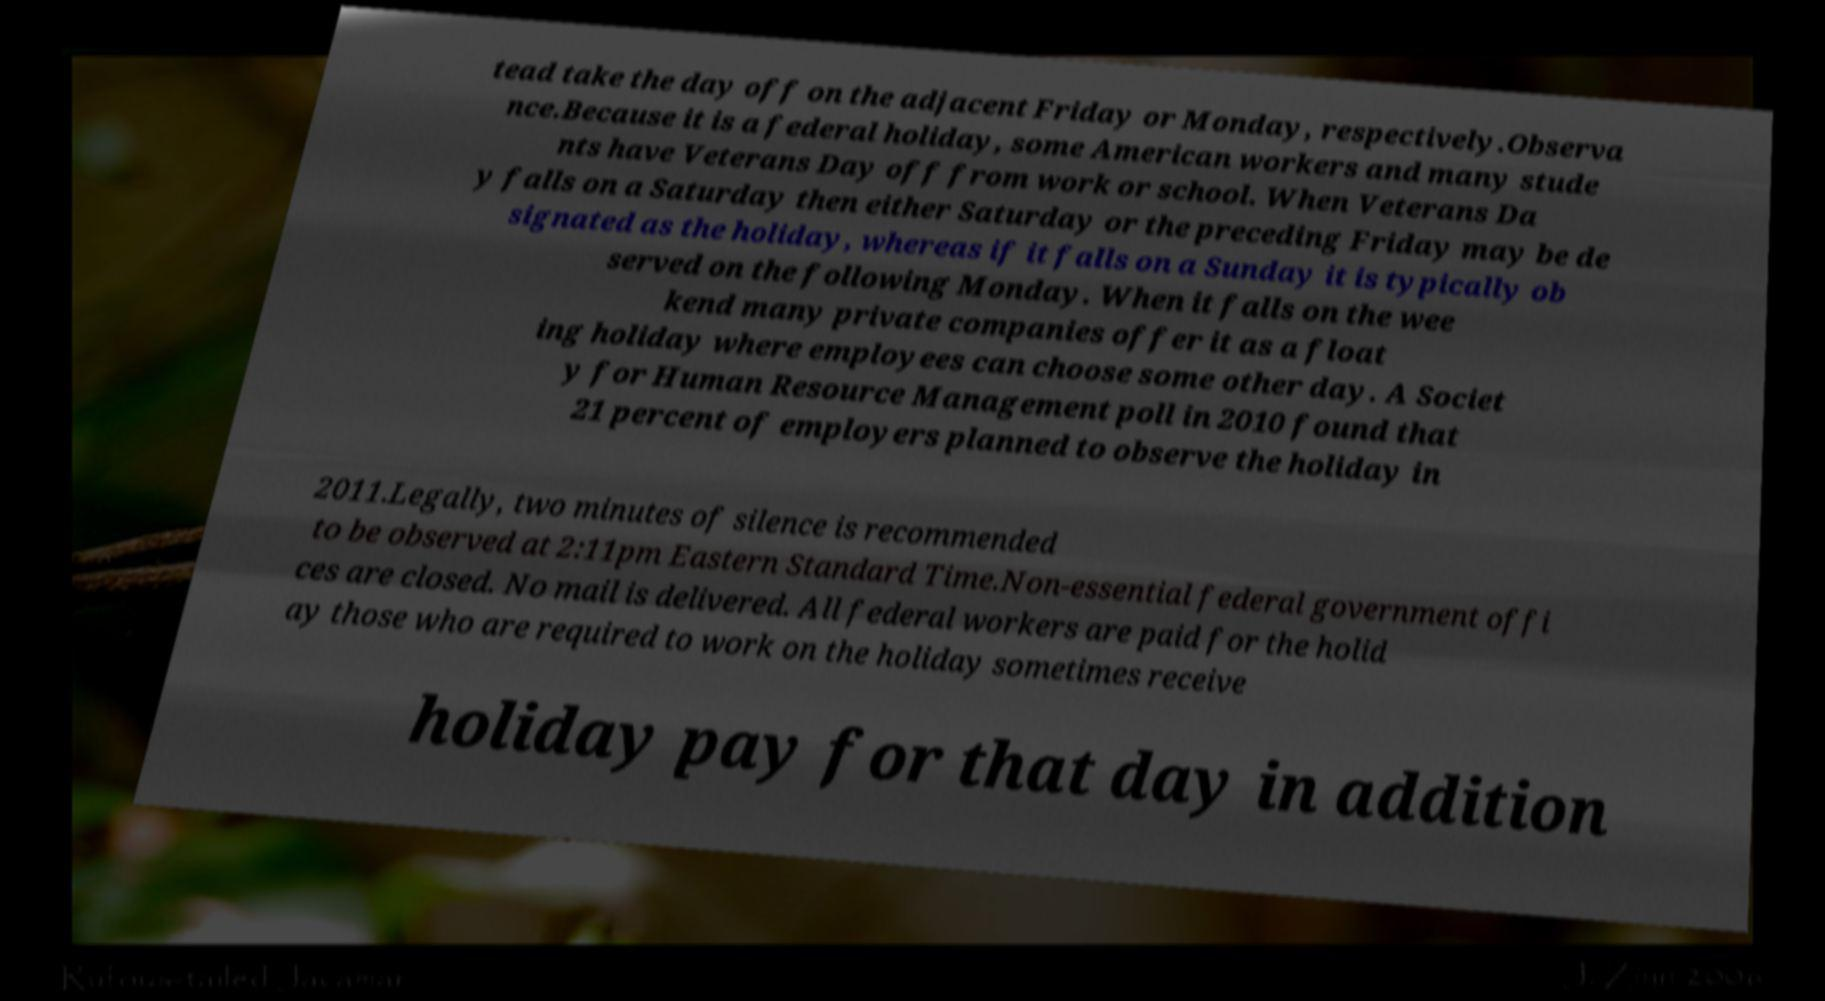Could you extract and type out the text from this image? tead take the day off on the adjacent Friday or Monday, respectively.Observa nce.Because it is a federal holiday, some American workers and many stude nts have Veterans Day off from work or school. When Veterans Da y falls on a Saturday then either Saturday or the preceding Friday may be de signated as the holiday, whereas if it falls on a Sunday it is typically ob served on the following Monday. When it falls on the wee kend many private companies offer it as a float ing holiday where employees can choose some other day. A Societ y for Human Resource Management poll in 2010 found that 21 percent of employers planned to observe the holiday in 2011.Legally, two minutes of silence is recommended to be observed at 2:11pm Eastern Standard Time.Non-essential federal government offi ces are closed. No mail is delivered. All federal workers are paid for the holid ay those who are required to work on the holiday sometimes receive holiday pay for that day in addition 